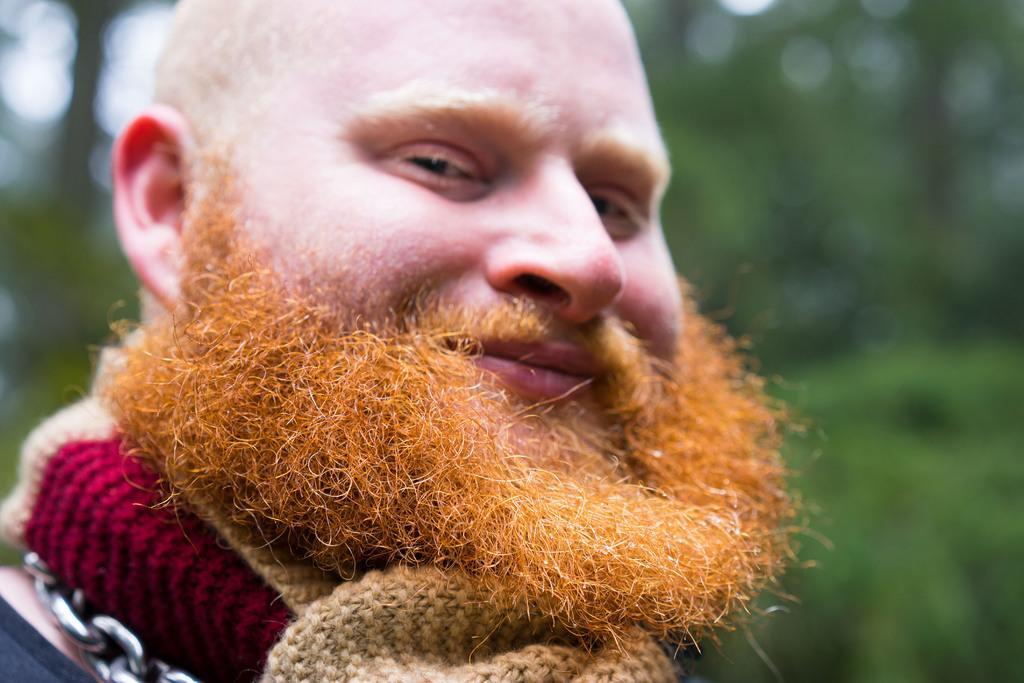Could you give a brief overview of what you see in this image? Here we can see a man and he is smiling. There is a blur background with greenery. 